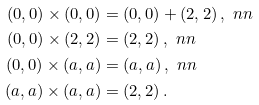<formula> <loc_0><loc_0><loc_500><loc_500>( 0 , 0 ) \times ( 0 , 0 ) & = ( 0 , 0 ) + ( 2 , 2 ) \, , \ n n \\ ( 0 , 0 ) \times ( 2 , 2 ) & = ( 2 , 2 ) \, , \ n n \\ ( 0 , 0 ) \times ( a , a ) & = ( a , a ) \, , \ n n \\ ( a , a ) \times ( a , a ) & = ( 2 , 2 ) \, .</formula> 